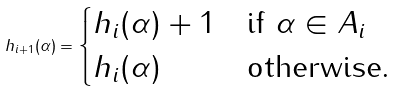Convert formula to latex. <formula><loc_0><loc_0><loc_500><loc_500>h _ { i + 1 } ( \alpha ) = \begin{cases} h _ { i } ( \alpha ) + 1 & \text {if $\alpha\in A_{i}$} \\ h _ { i } ( \alpha ) & \text {otherwise.} \end{cases}</formula> 